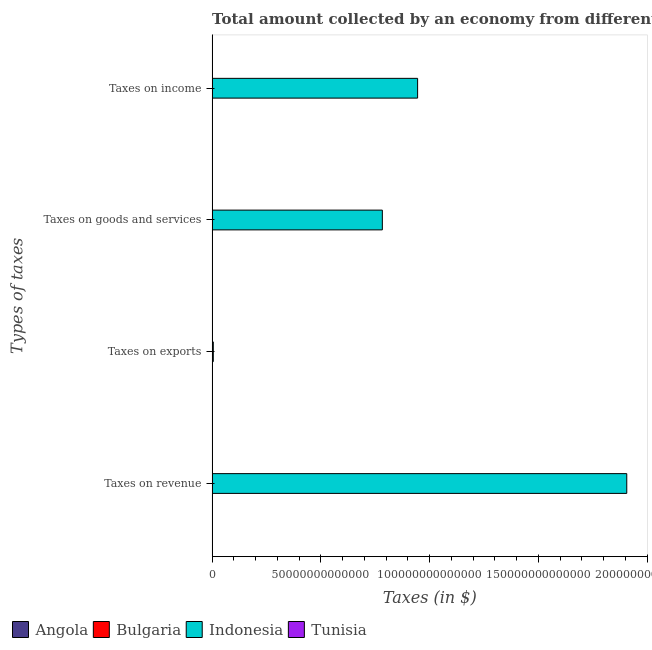How many different coloured bars are there?
Offer a terse response. 4. How many groups of bars are there?
Offer a terse response. 4. Are the number of bars per tick equal to the number of legend labels?
Offer a very short reply. Yes. How many bars are there on the 2nd tick from the bottom?
Offer a very short reply. 4. What is the label of the 2nd group of bars from the top?
Your response must be concise. Taxes on goods and services. What is the amount collected as tax on revenue in Indonesia?
Your response must be concise. 1.91e+14. Across all countries, what is the maximum amount collected as tax on income?
Offer a terse response. 9.45e+13. Across all countries, what is the minimum amount collected as tax on goods?
Ensure brevity in your answer.  3.16e+09. In which country was the amount collected as tax on exports minimum?
Your response must be concise. Bulgaria. What is the total amount collected as tax on income in the graph?
Offer a terse response. 9.45e+13. What is the difference between the amount collected as tax on goods in Angola and that in Indonesia?
Keep it short and to the point. -7.82e+13. What is the difference between the amount collected as tax on revenue in Tunisia and the amount collected as tax on income in Angola?
Give a very brief answer. -2.94e+1. What is the average amount collected as tax on revenue per country?
Your response must be concise. 4.77e+13. What is the difference between the amount collected as tax on income and amount collected as tax on revenue in Indonesia?
Your answer should be very brief. -9.62e+13. What is the ratio of the amount collected as tax on revenue in Bulgaria to that in Angola?
Your answer should be very brief. 0.08. Is the amount collected as tax on income in Bulgaria less than that in Tunisia?
Your response must be concise. Yes. What is the difference between the highest and the second highest amount collected as tax on income?
Give a very brief answer. 9.44e+13. What is the difference between the highest and the lowest amount collected as tax on exports?
Keep it short and to the point. 5.42e+11. Is the sum of the amount collected as tax on goods in Tunisia and Angola greater than the maximum amount collected as tax on exports across all countries?
Keep it short and to the point. No. Is it the case that in every country, the sum of the amount collected as tax on exports and amount collected as tax on income is greater than the sum of amount collected as tax on revenue and amount collected as tax on goods?
Give a very brief answer. No. What does the 4th bar from the bottom in Taxes on income represents?
Give a very brief answer. Tunisia. How many countries are there in the graph?
Offer a terse response. 4. What is the difference between two consecutive major ticks on the X-axis?
Give a very brief answer. 5.00e+13. Are the values on the major ticks of X-axis written in scientific E-notation?
Provide a succinct answer. No. Does the graph contain grids?
Your answer should be very brief. No. How many legend labels are there?
Make the answer very short. 4. How are the legend labels stacked?
Your response must be concise. Horizontal. What is the title of the graph?
Give a very brief answer. Total amount collected by an economy from different taxes in 2001. Does "Bahrain" appear as one of the legend labels in the graph?
Keep it short and to the point. No. What is the label or title of the X-axis?
Provide a short and direct response. Taxes (in $). What is the label or title of the Y-axis?
Make the answer very short. Types of taxes. What is the Taxes (in $) of Angola in Taxes on revenue?
Make the answer very short. 6.15e+1. What is the Taxes (in $) in Bulgaria in Taxes on revenue?
Keep it short and to the point. 5.19e+09. What is the Taxes (in $) of Indonesia in Taxes on revenue?
Offer a terse response. 1.91e+14. What is the Taxes (in $) in Tunisia in Taxes on revenue?
Offer a very short reply. 6.22e+09. What is the Taxes (in $) of Angola in Taxes on exports?
Offer a terse response. 9.21e+07. What is the Taxes (in $) of Bulgaria in Taxes on exports?
Your response must be concise. 1.46e+04. What is the Taxes (in $) of Indonesia in Taxes on exports?
Offer a terse response. 5.42e+11. What is the Taxes (in $) of Tunisia in Taxes on exports?
Give a very brief answer. 9.30e+06. What is the Taxes (in $) in Angola in Taxes on goods and services?
Keep it short and to the point. 1.98e+1. What is the Taxes (in $) in Bulgaria in Taxes on goods and services?
Make the answer very short. 3.60e+09. What is the Taxes (in $) in Indonesia in Taxes on goods and services?
Give a very brief answer. 7.83e+13. What is the Taxes (in $) in Tunisia in Taxes on goods and services?
Provide a succinct answer. 3.16e+09. What is the Taxes (in $) in Angola in Taxes on income?
Your answer should be very brief. 3.56e+1. What is the Taxes (in $) of Bulgaria in Taxes on income?
Your response must be concise. 1.28e+09. What is the Taxes (in $) in Indonesia in Taxes on income?
Make the answer very short. 9.45e+13. What is the Taxes (in $) in Tunisia in Taxes on income?
Make the answer very short. 1.83e+09. Across all Types of taxes, what is the maximum Taxes (in $) in Angola?
Your response must be concise. 6.15e+1. Across all Types of taxes, what is the maximum Taxes (in $) of Bulgaria?
Keep it short and to the point. 5.19e+09. Across all Types of taxes, what is the maximum Taxes (in $) in Indonesia?
Offer a terse response. 1.91e+14. Across all Types of taxes, what is the maximum Taxes (in $) of Tunisia?
Offer a terse response. 6.22e+09. Across all Types of taxes, what is the minimum Taxes (in $) in Angola?
Your response must be concise. 9.21e+07. Across all Types of taxes, what is the minimum Taxes (in $) in Bulgaria?
Your answer should be very brief. 1.46e+04. Across all Types of taxes, what is the minimum Taxes (in $) of Indonesia?
Provide a succinct answer. 5.42e+11. Across all Types of taxes, what is the minimum Taxes (in $) in Tunisia?
Keep it short and to the point. 9.30e+06. What is the total Taxes (in $) of Angola in the graph?
Offer a terse response. 1.17e+11. What is the total Taxes (in $) of Bulgaria in the graph?
Offer a terse response. 1.01e+1. What is the total Taxes (in $) in Indonesia in the graph?
Keep it short and to the point. 3.64e+14. What is the total Taxes (in $) in Tunisia in the graph?
Give a very brief answer. 1.12e+1. What is the difference between the Taxes (in $) of Angola in Taxes on revenue and that in Taxes on exports?
Ensure brevity in your answer.  6.14e+1. What is the difference between the Taxes (in $) of Bulgaria in Taxes on revenue and that in Taxes on exports?
Keep it short and to the point. 5.19e+09. What is the difference between the Taxes (in $) in Indonesia in Taxes on revenue and that in Taxes on exports?
Ensure brevity in your answer.  1.90e+14. What is the difference between the Taxes (in $) in Tunisia in Taxes on revenue and that in Taxes on exports?
Your answer should be very brief. 6.21e+09. What is the difference between the Taxes (in $) of Angola in Taxes on revenue and that in Taxes on goods and services?
Your answer should be very brief. 4.16e+1. What is the difference between the Taxes (in $) of Bulgaria in Taxes on revenue and that in Taxes on goods and services?
Offer a terse response. 1.58e+09. What is the difference between the Taxes (in $) in Indonesia in Taxes on revenue and that in Taxes on goods and services?
Ensure brevity in your answer.  1.12e+14. What is the difference between the Taxes (in $) in Tunisia in Taxes on revenue and that in Taxes on goods and services?
Ensure brevity in your answer.  3.06e+09. What is the difference between the Taxes (in $) of Angola in Taxes on revenue and that in Taxes on income?
Provide a succinct answer. 2.59e+1. What is the difference between the Taxes (in $) in Bulgaria in Taxes on revenue and that in Taxes on income?
Offer a terse response. 3.91e+09. What is the difference between the Taxes (in $) of Indonesia in Taxes on revenue and that in Taxes on income?
Your answer should be very brief. 9.62e+13. What is the difference between the Taxes (in $) in Tunisia in Taxes on revenue and that in Taxes on income?
Give a very brief answer. 4.39e+09. What is the difference between the Taxes (in $) of Angola in Taxes on exports and that in Taxes on goods and services?
Offer a very short reply. -1.98e+1. What is the difference between the Taxes (in $) in Bulgaria in Taxes on exports and that in Taxes on goods and services?
Provide a short and direct response. -3.60e+09. What is the difference between the Taxes (in $) of Indonesia in Taxes on exports and that in Taxes on goods and services?
Provide a short and direct response. -7.77e+13. What is the difference between the Taxes (in $) of Tunisia in Taxes on exports and that in Taxes on goods and services?
Offer a terse response. -3.15e+09. What is the difference between the Taxes (in $) of Angola in Taxes on exports and that in Taxes on income?
Provide a short and direct response. -3.55e+1. What is the difference between the Taxes (in $) of Bulgaria in Taxes on exports and that in Taxes on income?
Your answer should be compact. -1.28e+09. What is the difference between the Taxes (in $) in Indonesia in Taxes on exports and that in Taxes on income?
Your answer should be very brief. -9.39e+13. What is the difference between the Taxes (in $) in Tunisia in Taxes on exports and that in Taxes on income?
Ensure brevity in your answer.  -1.82e+09. What is the difference between the Taxes (in $) in Angola in Taxes on goods and services and that in Taxes on income?
Offer a terse response. -1.57e+1. What is the difference between the Taxes (in $) in Bulgaria in Taxes on goods and services and that in Taxes on income?
Provide a succinct answer. 2.33e+09. What is the difference between the Taxes (in $) of Indonesia in Taxes on goods and services and that in Taxes on income?
Ensure brevity in your answer.  -1.62e+13. What is the difference between the Taxes (in $) in Tunisia in Taxes on goods and services and that in Taxes on income?
Provide a short and direct response. 1.33e+09. What is the difference between the Taxes (in $) of Angola in Taxes on revenue and the Taxes (in $) of Bulgaria in Taxes on exports?
Offer a very short reply. 6.15e+1. What is the difference between the Taxes (in $) of Angola in Taxes on revenue and the Taxes (in $) of Indonesia in Taxes on exports?
Keep it short and to the point. -4.81e+11. What is the difference between the Taxes (in $) in Angola in Taxes on revenue and the Taxes (in $) in Tunisia in Taxes on exports?
Your answer should be compact. 6.15e+1. What is the difference between the Taxes (in $) in Bulgaria in Taxes on revenue and the Taxes (in $) in Indonesia in Taxes on exports?
Offer a terse response. -5.37e+11. What is the difference between the Taxes (in $) in Bulgaria in Taxes on revenue and the Taxes (in $) in Tunisia in Taxes on exports?
Make the answer very short. 5.18e+09. What is the difference between the Taxes (in $) of Indonesia in Taxes on revenue and the Taxes (in $) of Tunisia in Taxes on exports?
Offer a terse response. 1.91e+14. What is the difference between the Taxes (in $) in Angola in Taxes on revenue and the Taxes (in $) in Bulgaria in Taxes on goods and services?
Your response must be concise. 5.79e+1. What is the difference between the Taxes (in $) in Angola in Taxes on revenue and the Taxes (in $) in Indonesia in Taxes on goods and services?
Offer a very short reply. -7.82e+13. What is the difference between the Taxes (in $) of Angola in Taxes on revenue and the Taxes (in $) of Tunisia in Taxes on goods and services?
Ensure brevity in your answer.  5.83e+1. What is the difference between the Taxes (in $) of Bulgaria in Taxes on revenue and the Taxes (in $) of Indonesia in Taxes on goods and services?
Offer a terse response. -7.82e+13. What is the difference between the Taxes (in $) in Bulgaria in Taxes on revenue and the Taxes (in $) in Tunisia in Taxes on goods and services?
Your response must be concise. 2.03e+09. What is the difference between the Taxes (in $) in Indonesia in Taxes on revenue and the Taxes (in $) in Tunisia in Taxes on goods and services?
Provide a short and direct response. 1.91e+14. What is the difference between the Taxes (in $) of Angola in Taxes on revenue and the Taxes (in $) of Bulgaria in Taxes on income?
Offer a terse response. 6.02e+1. What is the difference between the Taxes (in $) of Angola in Taxes on revenue and the Taxes (in $) of Indonesia in Taxes on income?
Your answer should be compact. -9.44e+13. What is the difference between the Taxes (in $) in Angola in Taxes on revenue and the Taxes (in $) in Tunisia in Taxes on income?
Provide a succinct answer. 5.96e+1. What is the difference between the Taxes (in $) in Bulgaria in Taxes on revenue and the Taxes (in $) in Indonesia in Taxes on income?
Offer a terse response. -9.45e+13. What is the difference between the Taxes (in $) in Bulgaria in Taxes on revenue and the Taxes (in $) in Tunisia in Taxes on income?
Offer a very short reply. 3.36e+09. What is the difference between the Taxes (in $) in Indonesia in Taxes on revenue and the Taxes (in $) in Tunisia in Taxes on income?
Ensure brevity in your answer.  1.91e+14. What is the difference between the Taxes (in $) in Angola in Taxes on exports and the Taxes (in $) in Bulgaria in Taxes on goods and services?
Keep it short and to the point. -3.51e+09. What is the difference between the Taxes (in $) in Angola in Taxes on exports and the Taxes (in $) in Indonesia in Taxes on goods and services?
Provide a succinct answer. -7.83e+13. What is the difference between the Taxes (in $) in Angola in Taxes on exports and the Taxes (in $) in Tunisia in Taxes on goods and services?
Offer a terse response. -3.07e+09. What is the difference between the Taxes (in $) in Bulgaria in Taxes on exports and the Taxes (in $) in Indonesia in Taxes on goods and services?
Your answer should be very brief. -7.83e+13. What is the difference between the Taxes (in $) in Bulgaria in Taxes on exports and the Taxes (in $) in Tunisia in Taxes on goods and services?
Your answer should be compact. -3.16e+09. What is the difference between the Taxes (in $) of Indonesia in Taxes on exports and the Taxes (in $) of Tunisia in Taxes on goods and services?
Keep it short and to the point. 5.39e+11. What is the difference between the Taxes (in $) in Angola in Taxes on exports and the Taxes (in $) in Bulgaria in Taxes on income?
Offer a terse response. -1.18e+09. What is the difference between the Taxes (in $) of Angola in Taxes on exports and the Taxes (in $) of Indonesia in Taxes on income?
Give a very brief answer. -9.45e+13. What is the difference between the Taxes (in $) in Angola in Taxes on exports and the Taxes (in $) in Tunisia in Taxes on income?
Your answer should be very brief. -1.74e+09. What is the difference between the Taxes (in $) of Bulgaria in Taxes on exports and the Taxes (in $) of Indonesia in Taxes on income?
Your response must be concise. -9.45e+13. What is the difference between the Taxes (in $) in Bulgaria in Taxes on exports and the Taxes (in $) in Tunisia in Taxes on income?
Your response must be concise. -1.83e+09. What is the difference between the Taxes (in $) of Indonesia in Taxes on exports and the Taxes (in $) of Tunisia in Taxes on income?
Keep it short and to the point. 5.40e+11. What is the difference between the Taxes (in $) in Angola in Taxes on goods and services and the Taxes (in $) in Bulgaria in Taxes on income?
Provide a succinct answer. 1.86e+1. What is the difference between the Taxes (in $) of Angola in Taxes on goods and services and the Taxes (in $) of Indonesia in Taxes on income?
Make the answer very short. -9.44e+13. What is the difference between the Taxes (in $) of Angola in Taxes on goods and services and the Taxes (in $) of Tunisia in Taxes on income?
Offer a very short reply. 1.80e+1. What is the difference between the Taxes (in $) in Bulgaria in Taxes on goods and services and the Taxes (in $) in Indonesia in Taxes on income?
Keep it short and to the point. -9.45e+13. What is the difference between the Taxes (in $) of Bulgaria in Taxes on goods and services and the Taxes (in $) of Tunisia in Taxes on income?
Provide a short and direct response. 1.78e+09. What is the difference between the Taxes (in $) in Indonesia in Taxes on goods and services and the Taxes (in $) in Tunisia in Taxes on income?
Your answer should be very brief. 7.83e+13. What is the average Taxes (in $) in Angola per Types of taxes?
Provide a succinct answer. 2.92e+1. What is the average Taxes (in $) in Bulgaria per Types of taxes?
Your response must be concise. 2.52e+09. What is the average Taxes (in $) in Indonesia per Types of taxes?
Your answer should be very brief. 9.10e+13. What is the average Taxes (in $) in Tunisia per Types of taxes?
Ensure brevity in your answer.  2.80e+09. What is the difference between the Taxes (in $) of Angola and Taxes (in $) of Bulgaria in Taxes on revenue?
Provide a succinct answer. 5.63e+1. What is the difference between the Taxes (in $) of Angola and Taxes (in $) of Indonesia in Taxes on revenue?
Give a very brief answer. -1.91e+14. What is the difference between the Taxes (in $) of Angola and Taxes (in $) of Tunisia in Taxes on revenue?
Keep it short and to the point. 5.53e+1. What is the difference between the Taxes (in $) in Bulgaria and Taxes (in $) in Indonesia in Taxes on revenue?
Your answer should be very brief. -1.91e+14. What is the difference between the Taxes (in $) of Bulgaria and Taxes (in $) of Tunisia in Taxes on revenue?
Provide a succinct answer. -1.04e+09. What is the difference between the Taxes (in $) in Indonesia and Taxes (in $) in Tunisia in Taxes on revenue?
Keep it short and to the point. 1.91e+14. What is the difference between the Taxes (in $) of Angola and Taxes (in $) of Bulgaria in Taxes on exports?
Make the answer very short. 9.20e+07. What is the difference between the Taxes (in $) in Angola and Taxes (in $) in Indonesia in Taxes on exports?
Your response must be concise. -5.42e+11. What is the difference between the Taxes (in $) in Angola and Taxes (in $) in Tunisia in Taxes on exports?
Offer a terse response. 8.28e+07. What is the difference between the Taxes (in $) in Bulgaria and Taxes (in $) in Indonesia in Taxes on exports?
Provide a succinct answer. -5.42e+11. What is the difference between the Taxes (in $) in Bulgaria and Taxes (in $) in Tunisia in Taxes on exports?
Offer a very short reply. -9.29e+06. What is the difference between the Taxes (in $) of Indonesia and Taxes (in $) of Tunisia in Taxes on exports?
Provide a short and direct response. 5.42e+11. What is the difference between the Taxes (in $) in Angola and Taxes (in $) in Bulgaria in Taxes on goods and services?
Ensure brevity in your answer.  1.62e+1. What is the difference between the Taxes (in $) in Angola and Taxes (in $) in Indonesia in Taxes on goods and services?
Give a very brief answer. -7.82e+13. What is the difference between the Taxes (in $) of Angola and Taxes (in $) of Tunisia in Taxes on goods and services?
Make the answer very short. 1.67e+1. What is the difference between the Taxes (in $) of Bulgaria and Taxes (in $) of Indonesia in Taxes on goods and services?
Your response must be concise. -7.83e+13. What is the difference between the Taxes (in $) in Bulgaria and Taxes (in $) in Tunisia in Taxes on goods and services?
Your answer should be compact. 4.47e+08. What is the difference between the Taxes (in $) in Indonesia and Taxes (in $) in Tunisia in Taxes on goods and services?
Your answer should be compact. 7.83e+13. What is the difference between the Taxes (in $) of Angola and Taxes (in $) of Bulgaria in Taxes on income?
Your answer should be compact. 3.43e+1. What is the difference between the Taxes (in $) of Angola and Taxes (in $) of Indonesia in Taxes on income?
Your answer should be very brief. -9.44e+13. What is the difference between the Taxes (in $) of Angola and Taxes (in $) of Tunisia in Taxes on income?
Your response must be concise. 3.38e+1. What is the difference between the Taxes (in $) of Bulgaria and Taxes (in $) of Indonesia in Taxes on income?
Provide a succinct answer. -9.45e+13. What is the difference between the Taxes (in $) of Bulgaria and Taxes (in $) of Tunisia in Taxes on income?
Give a very brief answer. -5.51e+08. What is the difference between the Taxes (in $) in Indonesia and Taxes (in $) in Tunisia in Taxes on income?
Give a very brief answer. 9.45e+13. What is the ratio of the Taxes (in $) in Angola in Taxes on revenue to that in Taxes on exports?
Make the answer very short. 667.83. What is the ratio of the Taxes (in $) of Bulgaria in Taxes on revenue to that in Taxes on exports?
Your answer should be very brief. 3.55e+05. What is the ratio of the Taxes (in $) in Indonesia in Taxes on revenue to that in Taxes on exports?
Your answer should be compact. 351.49. What is the ratio of the Taxes (in $) in Tunisia in Taxes on revenue to that in Taxes on exports?
Provide a short and direct response. 668.98. What is the ratio of the Taxes (in $) of Angola in Taxes on revenue to that in Taxes on goods and services?
Ensure brevity in your answer.  3.1. What is the ratio of the Taxes (in $) of Bulgaria in Taxes on revenue to that in Taxes on goods and services?
Provide a short and direct response. 1.44. What is the ratio of the Taxes (in $) in Indonesia in Taxes on revenue to that in Taxes on goods and services?
Keep it short and to the point. 2.44. What is the ratio of the Taxes (in $) in Tunisia in Taxes on revenue to that in Taxes on goods and services?
Offer a very short reply. 1.97. What is the ratio of the Taxes (in $) in Angola in Taxes on revenue to that in Taxes on income?
Your response must be concise. 1.73. What is the ratio of the Taxes (in $) in Bulgaria in Taxes on revenue to that in Taxes on income?
Keep it short and to the point. 4.06. What is the ratio of the Taxes (in $) in Indonesia in Taxes on revenue to that in Taxes on income?
Keep it short and to the point. 2.02. What is the ratio of the Taxes (in $) of Tunisia in Taxes on revenue to that in Taxes on income?
Provide a succinct answer. 3.4. What is the ratio of the Taxes (in $) in Angola in Taxes on exports to that in Taxes on goods and services?
Provide a succinct answer. 0. What is the ratio of the Taxes (in $) in Indonesia in Taxes on exports to that in Taxes on goods and services?
Your answer should be compact. 0.01. What is the ratio of the Taxes (in $) in Tunisia in Taxes on exports to that in Taxes on goods and services?
Provide a short and direct response. 0. What is the ratio of the Taxes (in $) in Angola in Taxes on exports to that in Taxes on income?
Your answer should be very brief. 0. What is the ratio of the Taxes (in $) in Indonesia in Taxes on exports to that in Taxes on income?
Give a very brief answer. 0.01. What is the ratio of the Taxes (in $) of Tunisia in Taxes on exports to that in Taxes on income?
Keep it short and to the point. 0.01. What is the ratio of the Taxes (in $) in Angola in Taxes on goods and services to that in Taxes on income?
Your answer should be very brief. 0.56. What is the ratio of the Taxes (in $) in Bulgaria in Taxes on goods and services to that in Taxes on income?
Ensure brevity in your answer.  2.82. What is the ratio of the Taxes (in $) in Indonesia in Taxes on goods and services to that in Taxes on income?
Provide a short and direct response. 0.83. What is the ratio of the Taxes (in $) in Tunisia in Taxes on goods and services to that in Taxes on income?
Offer a terse response. 1.73. What is the difference between the highest and the second highest Taxes (in $) in Angola?
Give a very brief answer. 2.59e+1. What is the difference between the highest and the second highest Taxes (in $) in Bulgaria?
Your answer should be compact. 1.58e+09. What is the difference between the highest and the second highest Taxes (in $) in Indonesia?
Offer a terse response. 9.62e+13. What is the difference between the highest and the second highest Taxes (in $) in Tunisia?
Ensure brevity in your answer.  3.06e+09. What is the difference between the highest and the lowest Taxes (in $) in Angola?
Your answer should be very brief. 6.14e+1. What is the difference between the highest and the lowest Taxes (in $) in Bulgaria?
Provide a succinct answer. 5.19e+09. What is the difference between the highest and the lowest Taxes (in $) of Indonesia?
Make the answer very short. 1.90e+14. What is the difference between the highest and the lowest Taxes (in $) in Tunisia?
Your answer should be very brief. 6.21e+09. 